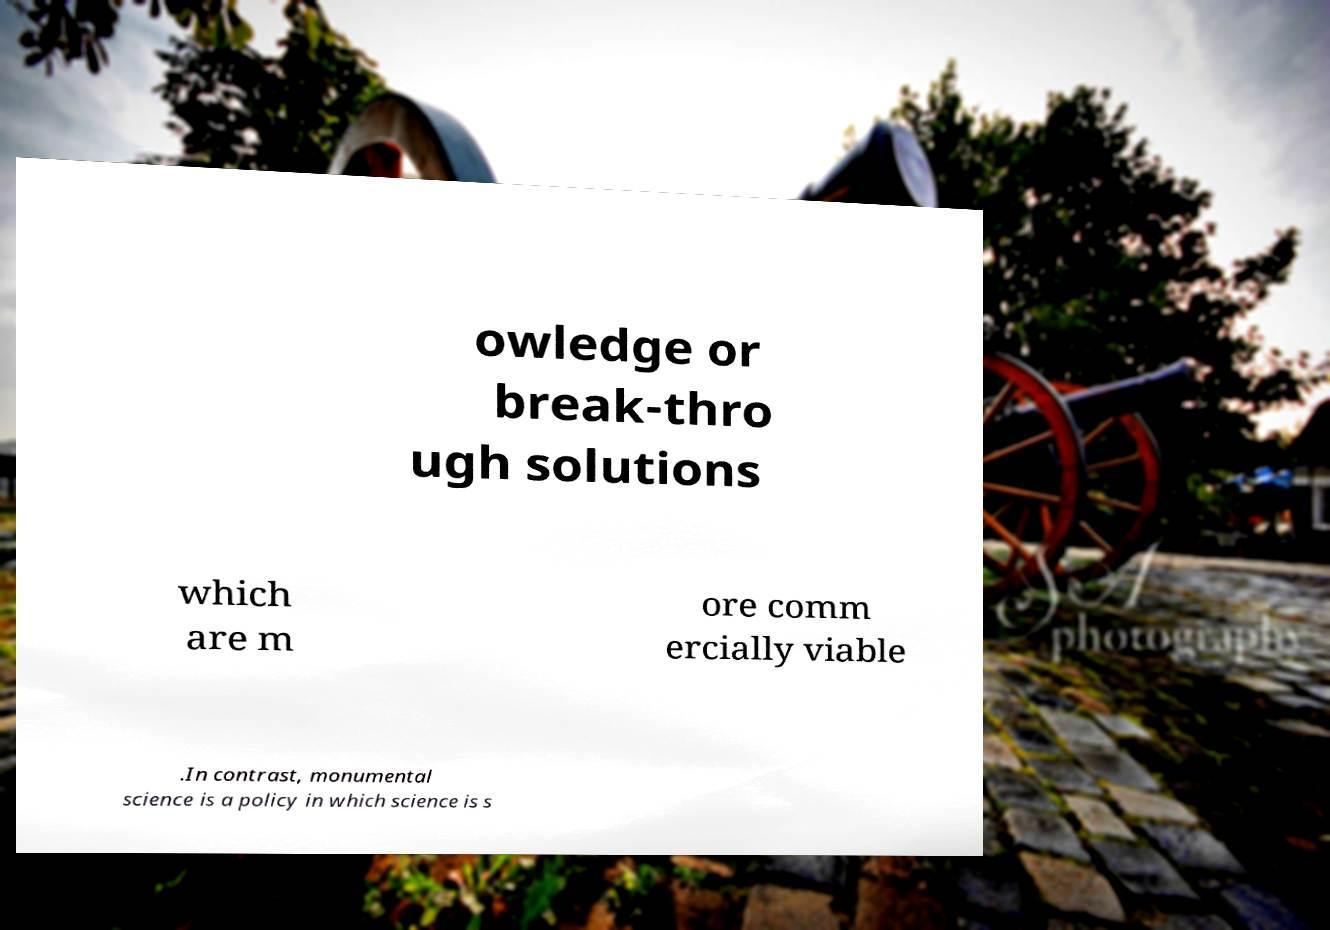Could you extract and type out the text from this image? owledge or break-thro ugh solutions which are m ore comm ercially viable .In contrast, monumental science is a policy in which science is s 